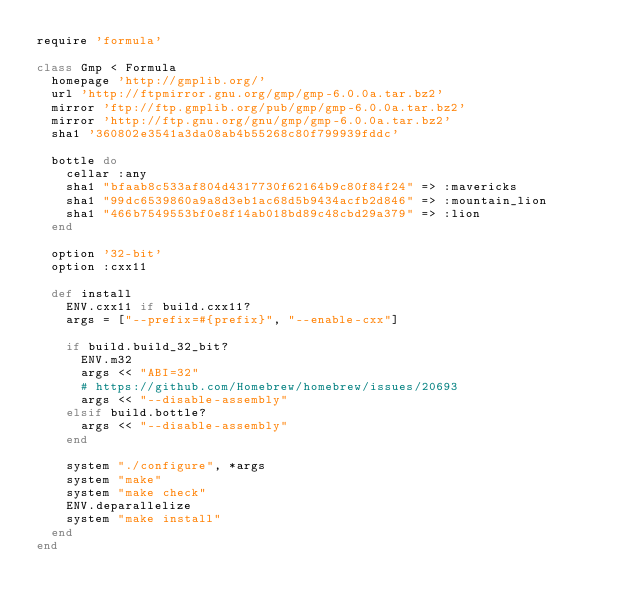Convert code to text. <code><loc_0><loc_0><loc_500><loc_500><_Ruby_>require 'formula'

class Gmp < Formula
  homepage 'http://gmplib.org/'
  url 'http://ftpmirror.gnu.org/gmp/gmp-6.0.0a.tar.bz2'
  mirror 'ftp://ftp.gmplib.org/pub/gmp/gmp-6.0.0a.tar.bz2'
  mirror 'http://ftp.gnu.org/gnu/gmp/gmp-6.0.0a.tar.bz2'
  sha1 '360802e3541a3da08ab4b55268c80f799939fddc'

  bottle do
    cellar :any
    sha1 "bfaab8c533af804d4317730f62164b9c80f84f24" => :mavericks
    sha1 "99dc6539860a9a8d3eb1ac68d5b9434acfb2d846" => :mountain_lion
    sha1 "466b7549553bf0e8f14ab018bd89c48cbd29a379" => :lion
  end

  option '32-bit'
  option :cxx11

  def install
    ENV.cxx11 if build.cxx11?
    args = ["--prefix=#{prefix}", "--enable-cxx"]

    if build.build_32_bit?
      ENV.m32
      args << "ABI=32"
      # https://github.com/Homebrew/homebrew/issues/20693
      args << "--disable-assembly"
    elsif build.bottle?
      args << "--disable-assembly"
    end

    system "./configure", *args
    system "make"
    system "make check"
    ENV.deparallelize
    system "make install"
  end
end
</code> 